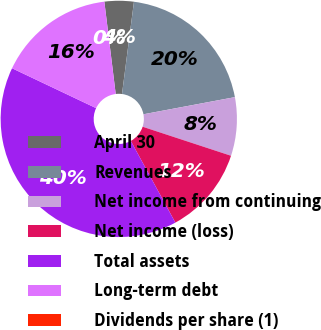Convert chart. <chart><loc_0><loc_0><loc_500><loc_500><pie_chart><fcel>April 30<fcel>Revenues<fcel>Net income from continuing<fcel>Net income (loss)<fcel>Total assets<fcel>Long-term debt<fcel>Dividends per share (1)<nl><fcel>4.0%<fcel>20.0%<fcel>8.0%<fcel>12.0%<fcel>40.0%<fcel>16.0%<fcel>0.0%<nl></chart> 